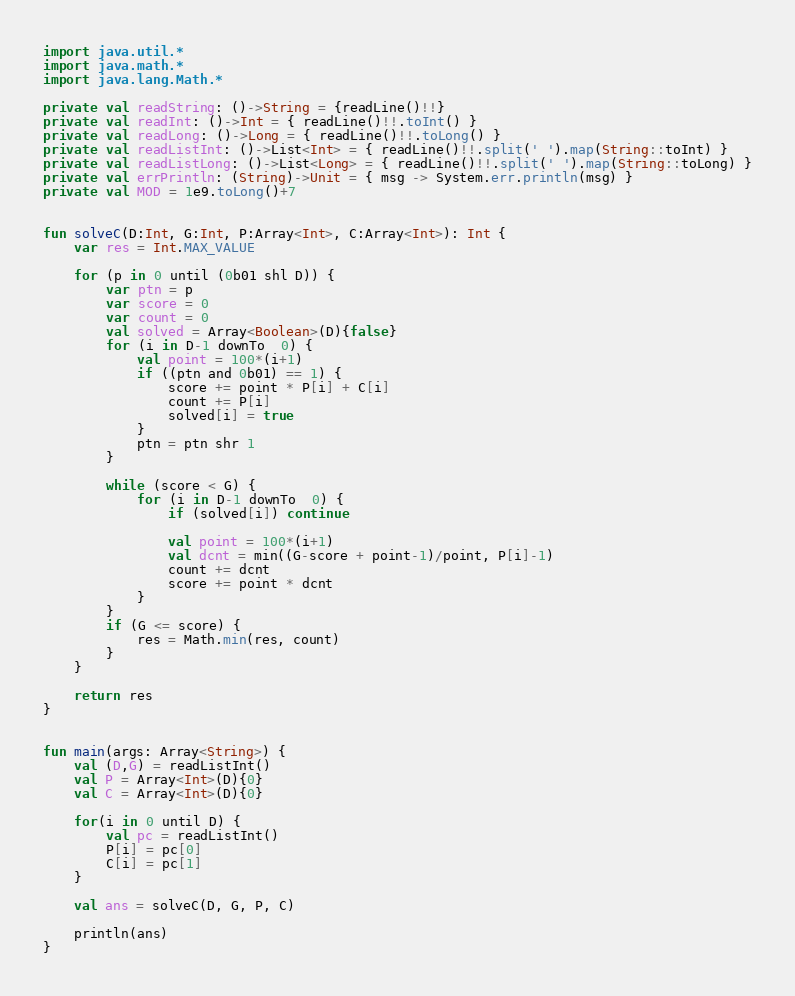Convert code to text. <code><loc_0><loc_0><loc_500><loc_500><_Kotlin_>import java.util.*
import java.math.*
import java.lang.Math.*

private val readString: ()->String = {readLine()!!}
private val readInt: ()->Int = { readLine()!!.toInt() }
private val readLong: ()->Long = { readLine()!!.toLong() }
private val readListInt: ()->List<Int> = { readLine()!!.split(' ').map(String::toInt) }
private val readListLong: ()->List<Long> = { readLine()!!.split(' ').map(String::toLong) }
private val errPrintln: (String)->Unit = { msg -> System.err.println(msg) }
private val MOD = 1e9.toLong()+7


fun solveC(D:Int, G:Int, P:Array<Int>, C:Array<Int>): Int {
    var res = Int.MAX_VALUE

    for (p in 0 until (0b01 shl D)) {
        var ptn = p
        var score = 0
        var count = 0
        val solved = Array<Boolean>(D){false}
        for (i in D-1 downTo  0) {
            val point = 100*(i+1)
            if ((ptn and 0b01) == 1) {
                score += point * P[i] + C[i]
                count += P[i]
                solved[i] = true
            }
            ptn = ptn shr 1
        }

        while (score < G) {
            for (i in D-1 downTo  0) {
                if (solved[i]) continue

                val point = 100*(i+1)
                val dcnt = min((G-score + point-1)/point, P[i]-1)
                count += dcnt
                score += point * dcnt
            }
        }
        if (G <= score) {
            res = Math.min(res, count)
        }
    }

    return res
}


fun main(args: Array<String>) {
    val (D,G) = readListInt()
    val P = Array<Int>(D){0}
    val C = Array<Int>(D){0}

    for(i in 0 until D) {
        val pc = readListInt()
        P[i] = pc[0]
        C[i] = pc[1]
    }

    val ans = solveC(D, G, P, C)

    println(ans)
}
</code> 